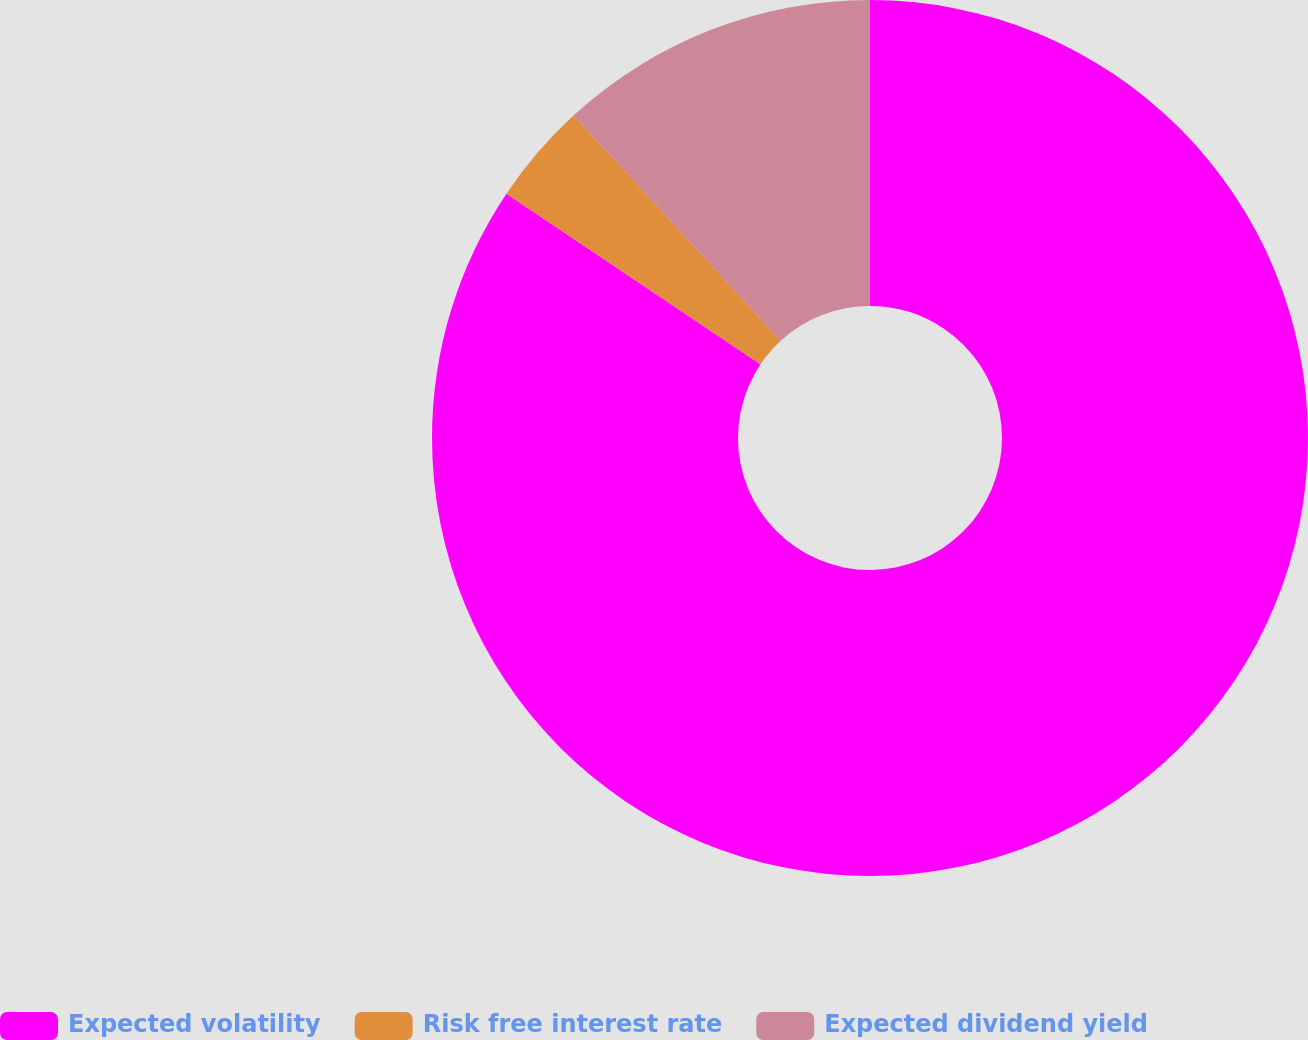Convert chart. <chart><loc_0><loc_0><loc_500><loc_500><pie_chart><fcel>Expected volatility<fcel>Risk free interest rate<fcel>Expected dividend yield<nl><fcel>84.42%<fcel>3.76%<fcel>11.82%<nl></chart> 